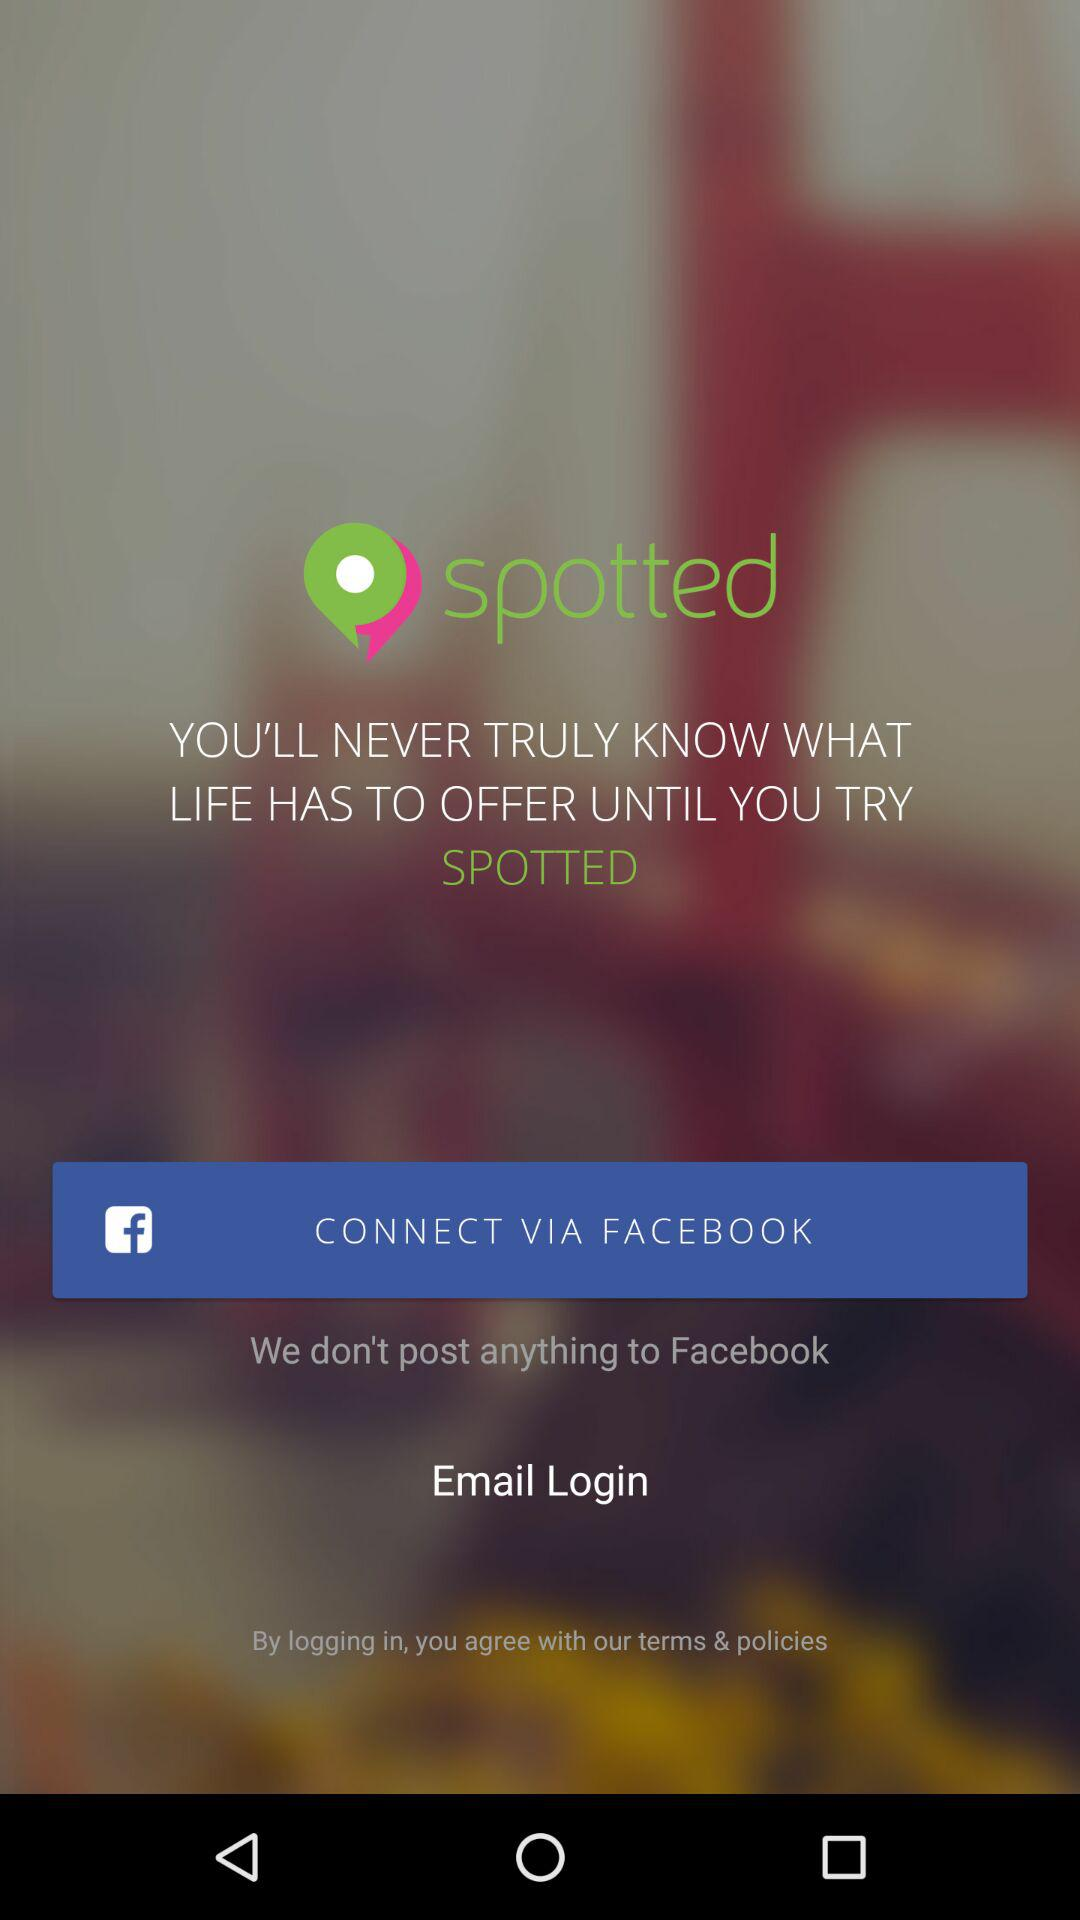Through what application can a user connect with? A user can connect with "FACEBOOK". 